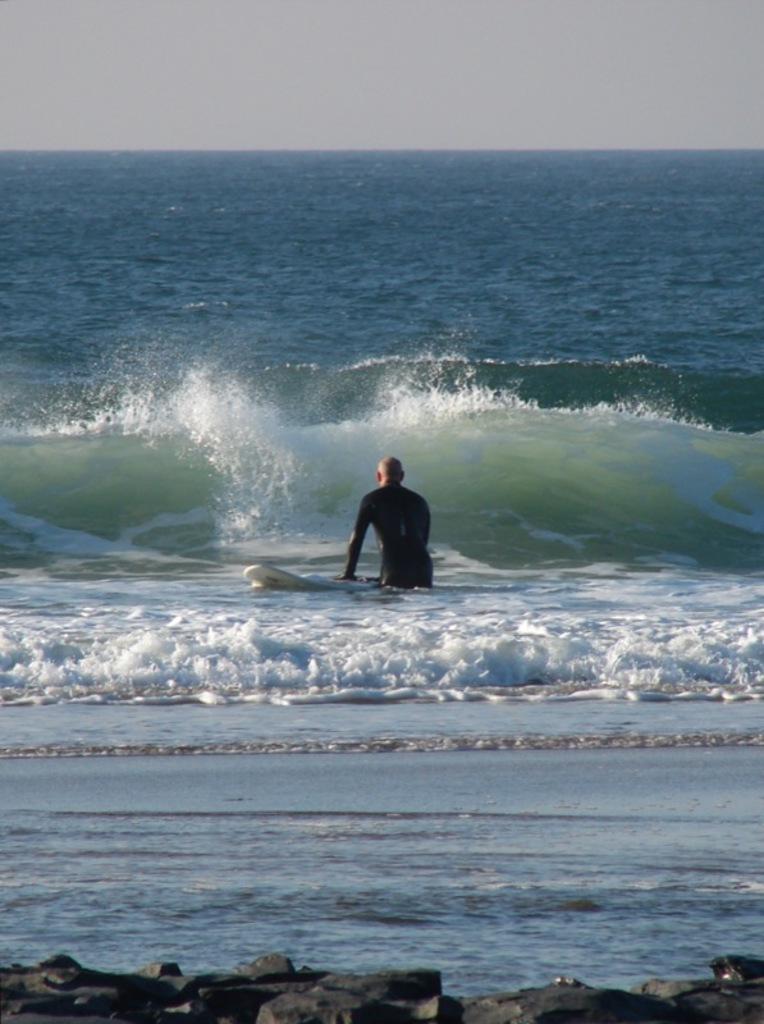Could you give a brief overview of what you see in this image? In this picture we can see stones at the bottom, in the background there is water, we can see a person and a surfboard in the middle, there is the sky at the top of the picture. 